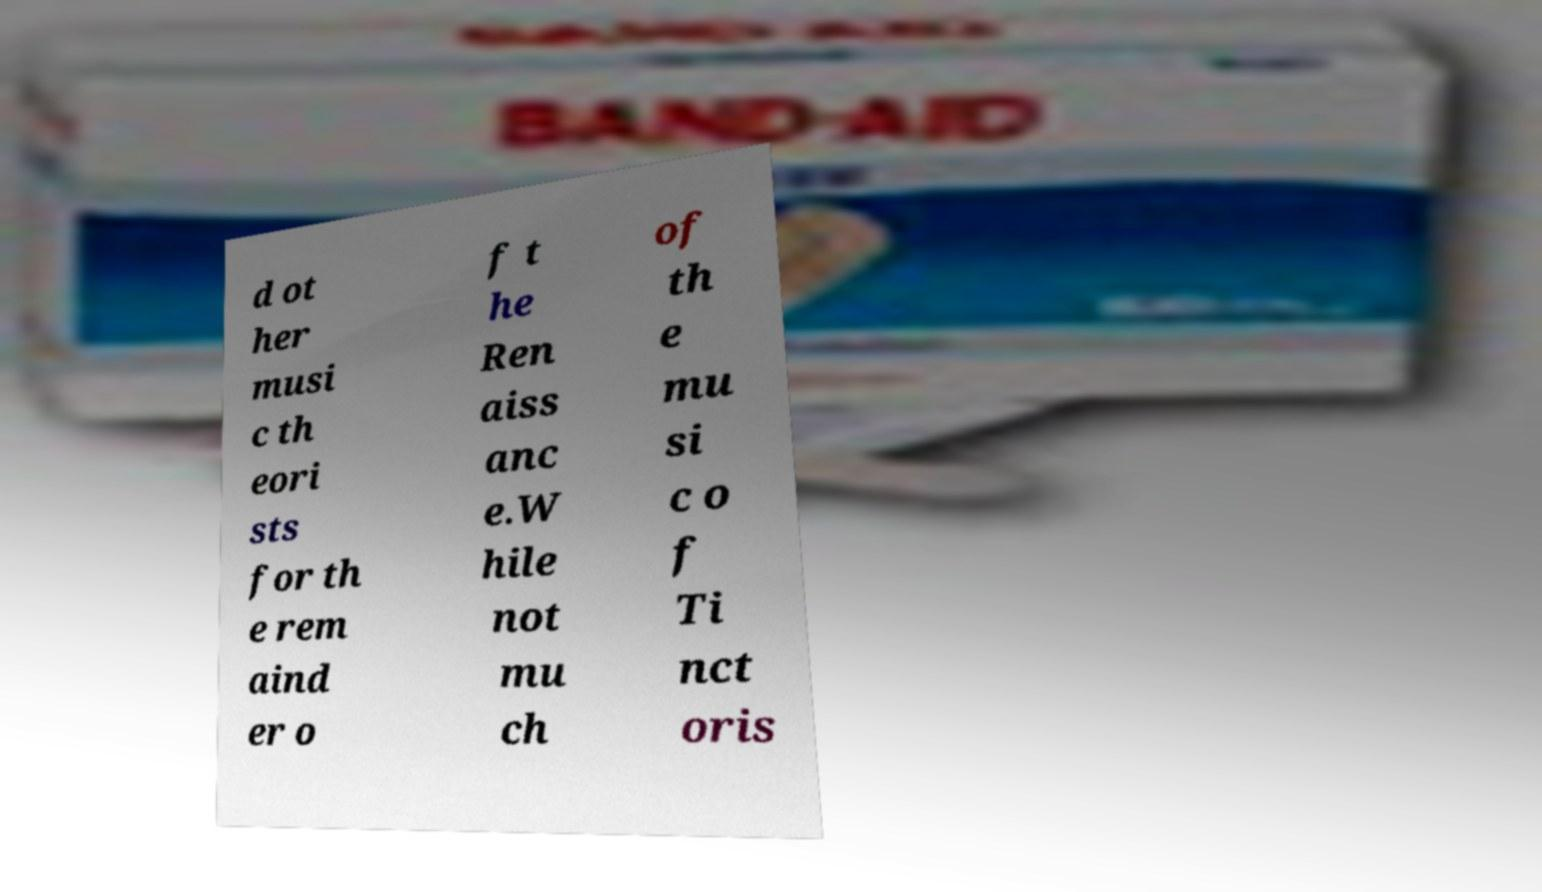Could you extract and type out the text from this image? d ot her musi c th eori sts for th e rem aind er o f t he Ren aiss anc e.W hile not mu ch of th e mu si c o f Ti nct oris 